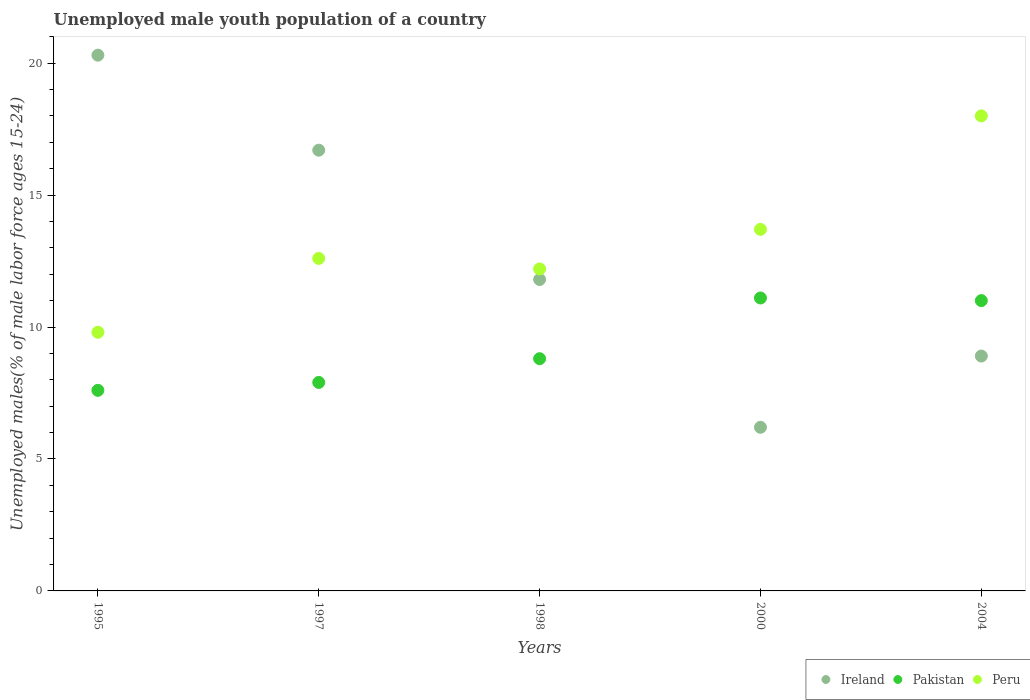What is the percentage of unemployed male youth population in Pakistan in 1997?
Your answer should be very brief. 7.9. Across all years, what is the maximum percentage of unemployed male youth population in Ireland?
Give a very brief answer. 20.3. Across all years, what is the minimum percentage of unemployed male youth population in Pakistan?
Provide a short and direct response. 7.6. In which year was the percentage of unemployed male youth population in Ireland minimum?
Offer a terse response. 2000. What is the total percentage of unemployed male youth population in Peru in the graph?
Keep it short and to the point. 66.3. What is the difference between the percentage of unemployed male youth population in Ireland in 1995 and that in 2004?
Your answer should be compact. 11.4. What is the difference between the percentage of unemployed male youth population in Ireland in 2004 and the percentage of unemployed male youth population in Pakistan in 2000?
Keep it short and to the point. -2.2. What is the average percentage of unemployed male youth population in Peru per year?
Make the answer very short. 13.26. In the year 2004, what is the difference between the percentage of unemployed male youth population in Peru and percentage of unemployed male youth population in Ireland?
Your answer should be very brief. 9.1. In how many years, is the percentage of unemployed male youth population in Peru greater than 4 %?
Keep it short and to the point. 5. What is the ratio of the percentage of unemployed male youth population in Ireland in 1998 to that in 2004?
Give a very brief answer. 1.33. What is the difference between the highest and the second highest percentage of unemployed male youth population in Peru?
Your answer should be very brief. 4.3. What is the difference between the highest and the lowest percentage of unemployed male youth population in Ireland?
Give a very brief answer. 14.1. In how many years, is the percentage of unemployed male youth population in Ireland greater than the average percentage of unemployed male youth population in Ireland taken over all years?
Make the answer very short. 2. Is it the case that in every year, the sum of the percentage of unemployed male youth population in Peru and percentage of unemployed male youth population in Pakistan  is greater than the percentage of unemployed male youth population in Ireland?
Provide a succinct answer. No. What is the difference between two consecutive major ticks on the Y-axis?
Provide a succinct answer. 5. Are the values on the major ticks of Y-axis written in scientific E-notation?
Provide a succinct answer. No. Does the graph contain any zero values?
Offer a very short reply. No. How are the legend labels stacked?
Provide a short and direct response. Horizontal. What is the title of the graph?
Give a very brief answer. Unemployed male youth population of a country. Does "St. Lucia" appear as one of the legend labels in the graph?
Ensure brevity in your answer.  No. What is the label or title of the Y-axis?
Give a very brief answer. Unemployed males(% of male labor force ages 15-24). What is the Unemployed males(% of male labor force ages 15-24) in Ireland in 1995?
Give a very brief answer. 20.3. What is the Unemployed males(% of male labor force ages 15-24) of Pakistan in 1995?
Offer a terse response. 7.6. What is the Unemployed males(% of male labor force ages 15-24) of Peru in 1995?
Provide a succinct answer. 9.8. What is the Unemployed males(% of male labor force ages 15-24) in Ireland in 1997?
Your response must be concise. 16.7. What is the Unemployed males(% of male labor force ages 15-24) of Pakistan in 1997?
Ensure brevity in your answer.  7.9. What is the Unemployed males(% of male labor force ages 15-24) in Peru in 1997?
Your response must be concise. 12.6. What is the Unemployed males(% of male labor force ages 15-24) in Ireland in 1998?
Offer a terse response. 11.8. What is the Unemployed males(% of male labor force ages 15-24) of Pakistan in 1998?
Your response must be concise. 8.8. What is the Unemployed males(% of male labor force ages 15-24) in Peru in 1998?
Make the answer very short. 12.2. What is the Unemployed males(% of male labor force ages 15-24) of Ireland in 2000?
Provide a short and direct response. 6.2. What is the Unemployed males(% of male labor force ages 15-24) of Pakistan in 2000?
Offer a very short reply. 11.1. What is the Unemployed males(% of male labor force ages 15-24) in Peru in 2000?
Offer a very short reply. 13.7. What is the Unemployed males(% of male labor force ages 15-24) of Ireland in 2004?
Offer a very short reply. 8.9. Across all years, what is the maximum Unemployed males(% of male labor force ages 15-24) of Ireland?
Make the answer very short. 20.3. Across all years, what is the maximum Unemployed males(% of male labor force ages 15-24) in Pakistan?
Make the answer very short. 11.1. Across all years, what is the maximum Unemployed males(% of male labor force ages 15-24) in Peru?
Your answer should be very brief. 18. Across all years, what is the minimum Unemployed males(% of male labor force ages 15-24) in Ireland?
Make the answer very short. 6.2. Across all years, what is the minimum Unemployed males(% of male labor force ages 15-24) of Pakistan?
Offer a terse response. 7.6. Across all years, what is the minimum Unemployed males(% of male labor force ages 15-24) in Peru?
Make the answer very short. 9.8. What is the total Unemployed males(% of male labor force ages 15-24) of Ireland in the graph?
Provide a short and direct response. 63.9. What is the total Unemployed males(% of male labor force ages 15-24) of Pakistan in the graph?
Give a very brief answer. 46.4. What is the total Unemployed males(% of male labor force ages 15-24) in Peru in the graph?
Provide a short and direct response. 66.3. What is the difference between the Unemployed males(% of male labor force ages 15-24) of Ireland in 1995 and that in 1997?
Provide a succinct answer. 3.6. What is the difference between the Unemployed males(% of male labor force ages 15-24) in Pakistan in 1995 and that in 2000?
Your answer should be very brief. -3.5. What is the difference between the Unemployed males(% of male labor force ages 15-24) in Pakistan in 1995 and that in 2004?
Offer a terse response. -3.4. What is the difference between the Unemployed males(% of male labor force ages 15-24) in Peru in 1995 and that in 2004?
Your answer should be very brief. -8.2. What is the difference between the Unemployed males(% of male labor force ages 15-24) in Ireland in 1997 and that in 1998?
Your response must be concise. 4.9. What is the difference between the Unemployed males(% of male labor force ages 15-24) in Peru in 1997 and that in 1998?
Keep it short and to the point. 0.4. What is the difference between the Unemployed males(% of male labor force ages 15-24) of Pakistan in 1997 and that in 2000?
Provide a succinct answer. -3.2. What is the difference between the Unemployed males(% of male labor force ages 15-24) in Peru in 1997 and that in 2004?
Give a very brief answer. -5.4. What is the difference between the Unemployed males(% of male labor force ages 15-24) of Pakistan in 1998 and that in 2000?
Give a very brief answer. -2.3. What is the difference between the Unemployed males(% of male labor force ages 15-24) in Peru in 1998 and that in 2000?
Offer a very short reply. -1.5. What is the difference between the Unemployed males(% of male labor force ages 15-24) in Pakistan in 1998 and that in 2004?
Provide a short and direct response. -2.2. What is the difference between the Unemployed males(% of male labor force ages 15-24) in Peru in 1998 and that in 2004?
Offer a very short reply. -5.8. What is the difference between the Unemployed males(% of male labor force ages 15-24) of Ireland in 2000 and that in 2004?
Give a very brief answer. -2.7. What is the difference between the Unemployed males(% of male labor force ages 15-24) in Pakistan in 2000 and that in 2004?
Make the answer very short. 0.1. What is the difference between the Unemployed males(% of male labor force ages 15-24) of Peru in 2000 and that in 2004?
Provide a succinct answer. -4.3. What is the difference between the Unemployed males(% of male labor force ages 15-24) in Ireland in 1995 and the Unemployed males(% of male labor force ages 15-24) in Pakistan in 1997?
Offer a very short reply. 12.4. What is the difference between the Unemployed males(% of male labor force ages 15-24) of Ireland in 1995 and the Unemployed males(% of male labor force ages 15-24) of Peru in 1997?
Make the answer very short. 7.7. What is the difference between the Unemployed males(% of male labor force ages 15-24) of Ireland in 1995 and the Unemployed males(% of male labor force ages 15-24) of Peru in 1998?
Your response must be concise. 8.1. What is the difference between the Unemployed males(% of male labor force ages 15-24) of Pakistan in 1995 and the Unemployed males(% of male labor force ages 15-24) of Peru in 1998?
Give a very brief answer. -4.6. What is the difference between the Unemployed males(% of male labor force ages 15-24) in Ireland in 1995 and the Unemployed males(% of male labor force ages 15-24) in Pakistan in 2000?
Keep it short and to the point. 9.2. What is the difference between the Unemployed males(% of male labor force ages 15-24) in Pakistan in 1995 and the Unemployed males(% of male labor force ages 15-24) in Peru in 2000?
Offer a terse response. -6.1. What is the difference between the Unemployed males(% of male labor force ages 15-24) in Ireland in 1995 and the Unemployed males(% of male labor force ages 15-24) in Pakistan in 2004?
Provide a succinct answer. 9.3. What is the difference between the Unemployed males(% of male labor force ages 15-24) in Ireland in 1995 and the Unemployed males(% of male labor force ages 15-24) in Peru in 2004?
Provide a short and direct response. 2.3. What is the difference between the Unemployed males(% of male labor force ages 15-24) in Ireland in 1997 and the Unemployed males(% of male labor force ages 15-24) in Peru in 1998?
Provide a short and direct response. 4.5. What is the difference between the Unemployed males(% of male labor force ages 15-24) of Ireland in 1997 and the Unemployed males(% of male labor force ages 15-24) of Pakistan in 2004?
Keep it short and to the point. 5.7. What is the difference between the Unemployed males(% of male labor force ages 15-24) in Ireland in 1997 and the Unemployed males(% of male labor force ages 15-24) in Peru in 2004?
Keep it short and to the point. -1.3. What is the difference between the Unemployed males(% of male labor force ages 15-24) in Pakistan in 1997 and the Unemployed males(% of male labor force ages 15-24) in Peru in 2004?
Ensure brevity in your answer.  -10.1. What is the difference between the Unemployed males(% of male labor force ages 15-24) in Ireland in 1998 and the Unemployed males(% of male labor force ages 15-24) in Peru in 2000?
Give a very brief answer. -1.9. What is the difference between the Unemployed males(% of male labor force ages 15-24) of Ireland in 1998 and the Unemployed males(% of male labor force ages 15-24) of Pakistan in 2004?
Your answer should be very brief. 0.8. What is the difference between the Unemployed males(% of male labor force ages 15-24) of Ireland in 1998 and the Unemployed males(% of male labor force ages 15-24) of Peru in 2004?
Offer a terse response. -6.2. What is the difference between the Unemployed males(% of male labor force ages 15-24) of Pakistan in 1998 and the Unemployed males(% of male labor force ages 15-24) of Peru in 2004?
Keep it short and to the point. -9.2. What is the difference between the Unemployed males(% of male labor force ages 15-24) in Ireland in 2000 and the Unemployed males(% of male labor force ages 15-24) in Pakistan in 2004?
Keep it short and to the point. -4.8. What is the difference between the Unemployed males(% of male labor force ages 15-24) of Ireland in 2000 and the Unemployed males(% of male labor force ages 15-24) of Peru in 2004?
Make the answer very short. -11.8. What is the difference between the Unemployed males(% of male labor force ages 15-24) in Pakistan in 2000 and the Unemployed males(% of male labor force ages 15-24) in Peru in 2004?
Make the answer very short. -6.9. What is the average Unemployed males(% of male labor force ages 15-24) of Ireland per year?
Your answer should be very brief. 12.78. What is the average Unemployed males(% of male labor force ages 15-24) in Pakistan per year?
Your answer should be compact. 9.28. What is the average Unemployed males(% of male labor force ages 15-24) of Peru per year?
Ensure brevity in your answer.  13.26. In the year 1995, what is the difference between the Unemployed males(% of male labor force ages 15-24) of Ireland and Unemployed males(% of male labor force ages 15-24) of Pakistan?
Give a very brief answer. 12.7. In the year 1995, what is the difference between the Unemployed males(% of male labor force ages 15-24) in Ireland and Unemployed males(% of male labor force ages 15-24) in Peru?
Offer a very short reply. 10.5. In the year 1997, what is the difference between the Unemployed males(% of male labor force ages 15-24) in Ireland and Unemployed males(% of male labor force ages 15-24) in Pakistan?
Your answer should be compact. 8.8. In the year 1997, what is the difference between the Unemployed males(% of male labor force ages 15-24) of Pakistan and Unemployed males(% of male labor force ages 15-24) of Peru?
Keep it short and to the point. -4.7. In the year 1998, what is the difference between the Unemployed males(% of male labor force ages 15-24) in Ireland and Unemployed males(% of male labor force ages 15-24) in Pakistan?
Provide a short and direct response. 3. In the year 2004, what is the difference between the Unemployed males(% of male labor force ages 15-24) of Pakistan and Unemployed males(% of male labor force ages 15-24) of Peru?
Ensure brevity in your answer.  -7. What is the ratio of the Unemployed males(% of male labor force ages 15-24) of Ireland in 1995 to that in 1997?
Your response must be concise. 1.22. What is the ratio of the Unemployed males(% of male labor force ages 15-24) of Pakistan in 1995 to that in 1997?
Provide a short and direct response. 0.96. What is the ratio of the Unemployed males(% of male labor force ages 15-24) of Ireland in 1995 to that in 1998?
Offer a very short reply. 1.72. What is the ratio of the Unemployed males(% of male labor force ages 15-24) in Pakistan in 1995 to that in 1998?
Give a very brief answer. 0.86. What is the ratio of the Unemployed males(% of male labor force ages 15-24) in Peru in 1995 to that in 1998?
Offer a very short reply. 0.8. What is the ratio of the Unemployed males(% of male labor force ages 15-24) in Ireland in 1995 to that in 2000?
Your answer should be compact. 3.27. What is the ratio of the Unemployed males(% of male labor force ages 15-24) of Pakistan in 1995 to that in 2000?
Provide a succinct answer. 0.68. What is the ratio of the Unemployed males(% of male labor force ages 15-24) of Peru in 1995 to that in 2000?
Provide a succinct answer. 0.72. What is the ratio of the Unemployed males(% of male labor force ages 15-24) in Ireland in 1995 to that in 2004?
Make the answer very short. 2.28. What is the ratio of the Unemployed males(% of male labor force ages 15-24) in Pakistan in 1995 to that in 2004?
Keep it short and to the point. 0.69. What is the ratio of the Unemployed males(% of male labor force ages 15-24) in Peru in 1995 to that in 2004?
Your answer should be compact. 0.54. What is the ratio of the Unemployed males(% of male labor force ages 15-24) in Ireland in 1997 to that in 1998?
Your answer should be compact. 1.42. What is the ratio of the Unemployed males(% of male labor force ages 15-24) of Pakistan in 1997 to that in 1998?
Provide a succinct answer. 0.9. What is the ratio of the Unemployed males(% of male labor force ages 15-24) of Peru in 1997 to that in 1998?
Your response must be concise. 1.03. What is the ratio of the Unemployed males(% of male labor force ages 15-24) in Ireland in 1997 to that in 2000?
Keep it short and to the point. 2.69. What is the ratio of the Unemployed males(% of male labor force ages 15-24) of Pakistan in 1997 to that in 2000?
Offer a very short reply. 0.71. What is the ratio of the Unemployed males(% of male labor force ages 15-24) of Peru in 1997 to that in 2000?
Your answer should be compact. 0.92. What is the ratio of the Unemployed males(% of male labor force ages 15-24) of Ireland in 1997 to that in 2004?
Your answer should be compact. 1.88. What is the ratio of the Unemployed males(% of male labor force ages 15-24) of Pakistan in 1997 to that in 2004?
Ensure brevity in your answer.  0.72. What is the ratio of the Unemployed males(% of male labor force ages 15-24) of Peru in 1997 to that in 2004?
Offer a terse response. 0.7. What is the ratio of the Unemployed males(% of male labor force ages 15-24) of Ireland in 1998 to that in 2000?
Make the answer very short. 1.9. What is the ratio of the Unemployed males(% of male labor force ages 15-24) in Pakistan in 1998 to that in 2000?
Your response must be concise. 0.79. What is the ratio of the Unemployed males(% of male labor force ages 15-24) of Peru in 1998 to that in 2000?
Make the answer very short. 0.89. What is the ratio of the Unemployed males(% of male labor force ages 15-24) of Ireland in 1998 to that in 2004?
Give a very brief answer. 1.33. What is the ratio of the Unemployed males(% of male labor force ages 15-24) of Pakistan in 1998 to that in 2004?
Your response must be concise. 0.8. What is the ratio of the Unemployed males(% of male labor force ages 15-24) of Peru in 1998 to that in 2004?
Give a very brief answer. 0.68. What is the ratio of the Unemployed males(% of male labor force ages 15-24) of Ireland in 2000 to that in 2004?
Your response must be concise. 0.7. What is the ratio of the Unemployed males(% of male labor force ages 15-24) in Pakistan in 2000 to that in 2004?
Provide a short and direct response. 1.01. What is the ratio of the Unemployed males(% of male labor force ages 15-24) of Peru in 2000 to that in 2004?
Offer a terse response. 0.76. What is the difference between the highest and the second highest Unemployed males(% of male labor force ages 15-24) in Ireland?
Offer a terse response. 3.6. What is the difference between the highest and the lowest Unemployed males(% of male labor force ages 15-24) of Ireland?
Provide a succinct answer. 14.1. 